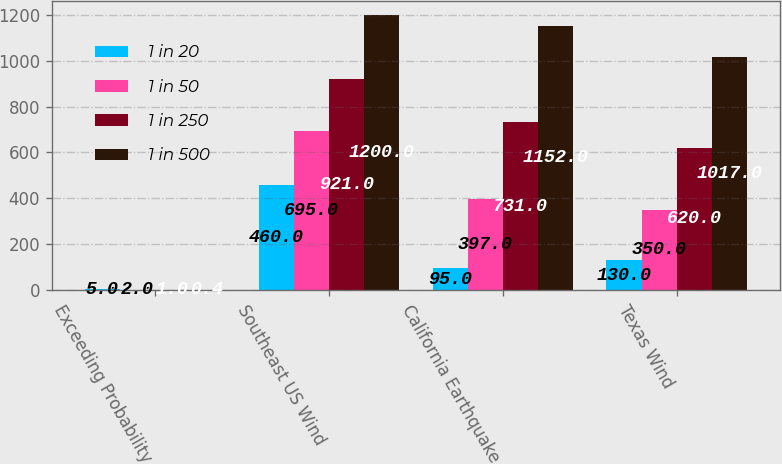Convert chart to OTSL. <chart><loc_0><loc_0><loc_500><loc_500><stacked_bar_chart><ecel><fcel>Exceeding Probability<fcel>Southeast US Wind<fcel>California Earthquake<fcel>Texas Wind<nl><fcel>1 in 20<fcel>5<fcel>460<fcel>95<fcel>130<nl><fcel>1 in 50<fcel>2<fcel>695<fcel>397<fcel>350<nl><fcel>1 in 250<fcel>1<fcel>921<fcel>731<fcel>620<nl><fcel>1 in 500<fcel>0.4<fcel>1200<fcel>1152<fcel>1017<nl></chart> 